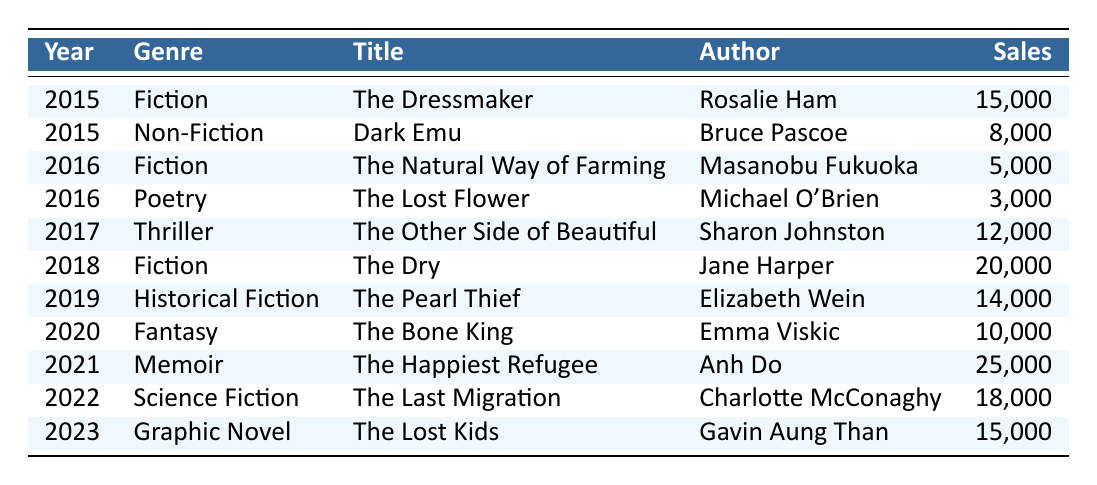What was the highest sales figure recorded in the table? The highest sales figure listed is 25,000 from the title "The Happiest Refugee" by Anh Do in 2021.
Answer: 25,000 In which year did "The Dry" achieve sales figures, and how many copies were sold? "The Dry" achieved sales figures in 2018 and had sales of 20,000 copies.
Answer: 2018, 20,000 How many more copies did "The Last Migration" sell compared to "The Other Side of Beautiful"? "The Last Migration" sold 18,000 copies, and "The Other Side of Beautiful" sold 12,000 copies. The difference is 18,000 - 12,000 = 6,000.
Answer: 6,000 Did any non-fiction work sell more than 10,000 copies in the table? Yes, the memoir "The Happiest Refugee" by Anh Do sold 25,000 copies, which is greater than 10,000 copies.
Answer: Yes What is the average sales figure for the fiction genre from 2015 to 2023? The sales figures for fiction are: 15,000 (2015), 5,000 (2016), 20,000 (2018). The average is calculated as (15,000 + 5,000 + 20,000) / 3 = 13,333.33.
Answer: 13,333.33 Which genre had the lowest total sales figures over the years presented? The total sales figures for each genre are as follows: Fiction (40,000), Non-Fiction (8,000), Poetry (3,000), Thriller (12,000), Historical Fiction (14,000), Fantasy (10,000), Memoir (25,000), Science Fiction (18,000), and Graphic Novel (15,000). Poetry had the lowest total sales with 3,000.
Answer: Poetry In what year did the sales figure for "Dark Emu" appear in the table, and how does it compare to the sales of "The Bone King"? "Dark Emu" appeared in 2015 with sales of 8,000, while "The Bone King" had sales of 10,000 in 2020. Comparing the two, "The Bone King" sold 2,000 more copies than "Dark Emu".
Answer: 2015, 2,000 more How many titles in the table are categorized as non-fiction? There is one title categorized as non-fiction, which is "Dark Emu" by Bruce Pascoe.
Answer: 1 Which year saw the least total sales across all genres? By examining the yearly sales: 2015 (23,000), 2016 (8,000), 2017 (12,000), 2018 (20,000), 2019 (14,000), 2020 (10,000), 2021 (25,000), 2022 (18,000), 2023 (15,000), 2016 has the least total sales at 8,000.
Answer: 2016 